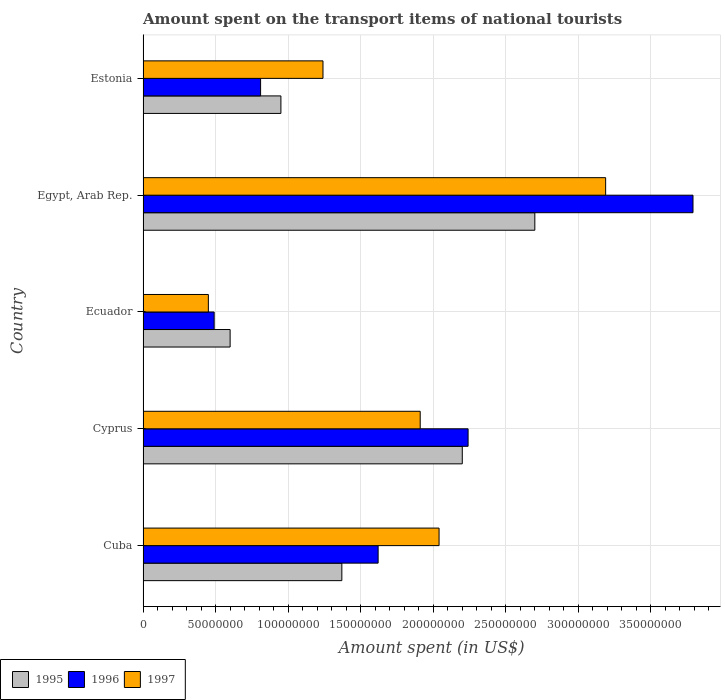How many groups of bars are there?
Your answer should be very brief. 5. Are the number of bars per tick equal to the number of legend labels?
Offer a terse response. Yes. What is the label of the 2nd group of bars from the top?
Your response must be concise. Egypt, Arab Rep. What is the amount spent on the transport items of national tourists in 1996 in Cuba?
Your response must be concise. 1.62e+08. Across all countries, what is the maximum amount spent on the transport items of national tourists in 1997?
Offer a very short reply. 3.19e+08. Across all countries, what is the minimum amount spent on the transport items of national tourists in 1996?
Provide a short and direct response. 4.90e+07. In which country was the amount spent on the transport items of national tourists in 1997 maximum?
Give a very brief answer. Egypt, Arab Rep. In which country was the amount spent on the transport items of national tourists in 1995 minimum?
Ensure brevity in your answer.  Ecuador. What is the total amount spent on the transport items of national tourists in 1995 in the graph?
Give a very brief answer. 7.82e+08. What is the difference between the amount spent on the transport items of national tourists in 1995 in Cuba and that in Estonia?
Make the answer very short. 4.20e+07. What is the difference between the amount spent on the transport items of national tourists in 1997 in Estonia and the amount spent on the transport items of national tourists in 1996 in Cyprus?
Offer a very short reply. -1.00e+08. What is the average amount spent on the transport items of national tourists in 1997 per country?
Give a very brief answer. 1.77e+08. What is the difference between the amount spent on the transport items of national tourists in 1995 and amount spent on the transport items of national tourists in 1997 in Ecuador?
Your answer should be compact. 1.50e+07. What is the ratio of the amount spent on the transport items of national tourists in 1997 in Cuba to that in Egypt, Arab Rep.?
Provide a succinct answer. 0.64. What is the difference between the highest and the second highest amount spent on the transport items of national tourists in 1997?
Make the answer very short. 1.15e+08. What is the difference between the highest and the lowest amount spent on the transport items of national tourists in 1997?
Make the answer very short. 2.74e+08. In how many countries, is the amount spent on the transport items of national tourists in 1996 greater than the average amount spent on the transport items of national tourists in 1996 taken over all countries?
Keep it short and to the point. 2. Is the sum of the amount spent on the transport items of national tourists in 1995 in Cuba and Egypt, Arab Rep. greater than the maximum amount spent on the transport items of national tourists in 1997 across all countries?
Offer a very short reply. Yes. What does the 1st bar from the top in Estonia represents?
Your answer should be very brief. 1997. What does the 2nd bar from the bottom in Egypt, Arab Rep. represents?
Provide a succinct answer. 1996. Is it the case that in every country, the sum of the amount spent on the transport items of national tourists in 1997 and amount spent on the transport items of national tourists in 1996 is greater than the amount spent on the transport items of national tourists in 1995?
Your response must be concise. Yes. How many countries are there in the graph?
Your answer should be very brief. 5. Does the graph contain any zero values?
Give a very brief answer. No. Does the graph contain grids?
Your response must be concise. Yes. How many legend labels are there?
Make the answer very short. 3. How are the legend labels stacked?
Your response must be concise. Horizontal. What is the title of the graph?
Keep it short and to the point. Amount spent on the transport items of national tourists. What is the label or title of the X-axis?
Offer a terse response. Amount spent (in US$). What is the label or title of the Y-axis?
Keep it short and to the point. Country. What is the Amount spent (in US$) in 1995 in Cuba?
Your answer should be compact. 1.37e+08. What is the Amount spent (in US$) of 1996 in Cuba?
Keep it short and to the point. 1.62e+08. What is the Amount spent (in US$) of 1997 in Cuba?
Your response must be concise. 2.04e+08. What is the Amount spent (in US$) of 1995 in Cyprus?
Keep it short and to the point. 2.20e+08. What is the Amount spent (in US$) in 1996 in Cyprus?
Give a very brief answer. 2.24e+08. What is the Amount spent (in US$) of 1997 in Cyprus?
Provide a succinct answer. 1.91e+08. What is the Amount spent (in US$) of 1995 in Ecuador?
Offer a very short reply. 6.00e+07. What is the Amount spent (in US$) in 1996 in Ecuador?
Offer a terse response. 4.90e+07. What is the Amount spent (in US$) in 1997 in Ecuador?
Ensure brevity in your answer.  4.50e+07. What is the Amount spent (in US$) of 1995 in Egypt, Arab Rep.?
Offer a terse response. 2.70e+08. What is the Amount spent (in US$) in 1996 in Egypt, Arab Rep.?
Offer a terse response. 3.79e+08. What is the Amount spent (in US$) of 1997 in Egypt, Arab Rep.?
Ensure brevity in your answer.  3.19e+08. What is the Amount spent (in US$) of 1995 in Estonia?
Ensure brevity in your answer.  9.50e+07. What is the Amount spent (in US$) of 1996 in Estonia?
Keep it short and to the point. 8.10e+07. What is the Amount spent (in US$) in 1997 in Estonia?
Your response must be concise. 1.24e+08. Across all countries, what is the maximum Amount spent (in US$) of 1995?
Give a very brief answer. 2.70e+08. Across all countries, what is the maximum Amount spent (in US$) of 1996?
Offer a very short reply. 3.79e+08. Across all countries, what is the maximum Amount spent (in US$) of 1997?
Provide a succinct answer. 3.19e+08. Across all countries, what is the minimum Amount spent (in US$) in 1995?
Offer a terse response. 6.00e+07. Across all countries, what is the minimum Amount spent (in US$) of 1996?
Your response must be concise. 4.90e+07. Across all countries, what is the minimum Amount spent (in US$) in 1997?
Give a very brief answer. 4.50e+07. What is the total Amount spent (in US$) of 1995 in the graph?
Provide a succinct answer. 7.82e+08. What is the total Amount spent (in US$) of 1996 in the graph?
Your answer should be compact. 8.95e+08. What is the total Amount spent (in US$) in 1997 in the graph?
Ensure brevity in your answer.  8.83e+08. What is the difference between the Amount spent (in US$) of 1995 in Cuba and that in Cyprus?
Your answer should be very brief. -8.30e+07. What is the difference between the Amount spent (in US$) in 1996 in Cuba and that in Cyprus?
Make the answer very short. -6.20e+07. What is the difference between the Amount spent (in US$) of 1997 in Cuba and that in Cyprus?
Provide a short and direct response. 1.30e+07. What is the difference between the Amount spent (in US$) in 1995 in Cuba and that in Ecuador?
Keep it short and to the point. 7.70e+07. What is the difference between the Amount spent (in US$) in 1996 in Cuba and that in Ecuador?
Ensure brevity in your answer.  1.13e+08. What is the difference between the Amount spent (in US$) in 1997 in Cuba and that in Ecuador?
Your answer should be very brief. 1.59e+08. What is the difference between the Amount spent (in US$) of 1995 in Cuba and that in Egypt, Arab Rep.?
Provide a short and direct response. -1.33e+08. What is the difference between the Amount spent (in US$) of 1996 in Cuba and that in Egypt, Arab Rep.?
Make the answer very short. -2.17e+08. What is the difference between the Amount spent (in US$) in 1997 in Cuba and that in Egypt, Arab Rep.?
Your response must be concise. -1.15e+08. What is the difference between the Amount spent (in US$) of 1995 in Cuba and that in Estonia?
Your response must be concise. 4.20e+07. What is the difference between the Amount spent (in US$) of 1996 in Cuba and that in Estonia?
Offer a terse response. 8.10e+07. What is the difference between the Amount spent (in US$) of 1997 in Cuba and that in Estonia?
Give a very brief answer. 8.00e+07. What is the difference between the Amount spent (in US$) of 1995 in Cyprus and that in Ecuador?
Provide a succinct answer. 1.60e+08. What is the difference between the Amount spent (in US$) of 1996 in Cyprus and that in Ecuador?
Provide a succinct answer. 1.75e+08. What is the difference between the Amount spent (in US$) of 1997 in Cyprus and that in Ecuador?
Your answer should be compact. 1.46e+08. What is the difference between the Amount spent (in US$) of 1995 in Cyprus and that in Egypt, Arab Rep.?
Offer a very short reply. -5.00e+07. What is the difference between the Amount spent (in US$) in 1996 in Cyprus and that in Egypt, Arab Rep.?
Offer a terse response. -1.55e+08. What is the difference between the Amount spent (in US$) of 1997 in Cyprus and that in Egypt, Arab Rep.?
Ensure brevity in your answer.  -1.28e+08. What is the difference between the Amount spent (in US$) of 1995 in Cyprus and that in Estonia?
Offer a terse response. 1.25e+08. What is the difference between the Amount spent (in US$) in 1996 in Cyprus and that in Estonia?
Offer a terse response. 1.43e+08. What is the difference between the Amount spent (in US$) of 1997 in Cyprus and that in Estonia?
Provide a succinct answer. 6.70e+07. What is the difference between the Amount spent (in US$) of 1995 in Ecuador and that in Egypt, Arab Rep.?
Provide a succinct answer. -2.10e+08. What is the difference between the Amount spent (in US$) of 1996 in Ecuador and that in Egypt, Arab Rep.?
Your answer should be compact. -3.30e+08. What is the difference between the Amount spent (in US$) in 1997 in Ecuador and that in Egypt, Arab Rep.?
Provide a short and direct response. -2.74e+08. What is the difference between the Amount spent (in US$) in 1995 in Ecuador and that in Estonia?
Your answer should be compact. -3.50e+07. What is the difference between the Amount spent (in US$) of 1996 in Ecuador and that in Estonia?
Your response must be concise. -3.20e+07. What is the difference between the Amount spent (in US$) in 1997 in Ecuador and that in Estonia?
Offer a very short reply. -7.90e+07. What is the difference between the Amount spent (in US$) of 1995 in Egypt, Arab Rep. and that in Estonia?
Provide a succinct answer. 1.75e+08. What is the difference between the Amount spent (in US$) of 1996 in Egypt, Arab Rep. and that in Estonia?
Give a very brief answer. 2.98e+08. What is the difference between the Amount spent (in US$) of 1997 in Egypt, Arab Rep. and that in Estonia?
Make the answer very short. 1.95e+08. What is the difference between the Amount spent (in US$) of 1995 in Cuba and the Amount spent (in US$) of 1996 in Cyprus?
Provide a succinct answer. -8.70e+07. What is the difference between the Amount spent (in US$) in 1995 in Cuba and the Amount spent (in US$) in 1997 in Cyprus?
Your answer should be compact. -5.40e+07. What is the difference between the Amount spent (in US$) of 1996 in Cuba and the Amount spent (in US$) of 1997 in Cyprus?
Offer a terse response. -2.90e+07. What is the difference between the Amount spent (in US$) in 1995 in Cuba and the Amount spent (in US$) in 1996 in Ecuador?
Your response must be concise. 8.80e+07. What is the difference between the Amount spent (in US$) in 1995 in Cuba and the Amount spent (in US$) in 1997 in Ecuador?
Your answer should be very brief. 9.20e+07. What is the difference between the Amount spent (in US$) of 1996 in Cuba and the Amount spent (in US$) of 1997 in Ecuador?
Your answer should be compact. 1.17e+08. What is the difference between the Amount spent (in US$) of 1995 in Cuba and the Amount spent (in US$) of 1996 in Egypt, Arab Rep.?
Give a very brief answer. -2.42e+08. What is the difference between the Amount spent (in US$) in 1995 in Cuba and the Amount spent (in US$) in 1997 in Egypt, Arab Rep.?
Ensure brevity in your answer.  -1.82e+08. What is the difference between the Amount spent (in US$) in 1996 in Cuba and the Amount spent (in US$) in 1997 in Egypt, Arab Rep.?
Make the answer very short. -1.57e+08. What is the difference between the Amount spent (in US$) in 1995 in Cuba and the Amount spent (in US$) in 1996 in Estonia?
Your answer should be compact. 5.60e+07. What is the difference between the Amount spent (in US$) of 1995 in Cuba and the Amount spent (in US$) of 1997 in Estonia?
Your answer should be compact. 1.30e+07. What is the difference between the Amount spent (in US$) of 1996 in Cuba and the Amount spent (in US$) of 1997 in Estonia?
Give a very brief answer. 3.80e+07. What is the difference between the Amount spent (in US$) of 1995 in Cyprus and the Amount spent (in US$) of 1996 in Ecuador?
Provide a short and direct response. 1.71e+08. What is the difference between the Amount spent (in US$) of 1995 in Cyprus and the Amount spent (in US$) of 1997 in Ecuador?
Keep it short and to the point. 1.75e+08. What is the difference between the Amount spent (in US$) of 1996 in Cyprus and the Amount spent (in US$) of 1997 in Ecuador?
Keep it short and to the point. 1.79e+08. What is the difference between the Amount spent (in US$) of 1995 in Cyprus and the Amount spent (in US$) of 1996 in Egypt, Arab Rep.?
Offer a very short reply. -1.59e+08. What is the difference between the Amount spent (in US$) in 1995 in Cyprus and the Amount spent (in US$) in 1997 in Egypt, Arab Rep.?
Your answer should be very brief. -9.88e+07. What is the difference between the Amount spent (in US$) in 1996 in Cyprus and the Amount spent (in US$) in 1997 in Egypt, Arab Rep.?
Your response must be concise. -9.48e+07. What is the difference between the Amount spent (in US$) in 1995 in Cyprus and the Amount spent (in US$) in 1996 in Estonia?
Your response must be concise. 1.39e+08. What is the difference between the Amount spent (in US$) of 1995 in Cyprus and the Amount spent (in US$) of 1997 in Estonia?
Your answer should be compact. 9.60e+07. What is the difference between the Amount spent (in US$) of 1996 in Cyprus and the Amount spent (in US$) of 1997 in Estonia?
Provide a short and direct response. 1.00e+08. What is the difference between the Amount spent (in US$) of 1995 in Ecuador and the Amount spent (in US$) of 1996 in Egypt, Arab Rep.?
Your answer should be very brief. -3.19e+08. What is the difference between the Amount spent (in US$) of 1995 in Ecuador and the Amount spent (in US$) of 1997 in Egypt, Arab Rep.?
Keep it short and to the point. -2.59e+08. What is the difference between the Amount spent (in US$) in 1996 in Ecuador and the Amount spent (in US$) in 1997 in Egypt, Arab Rep.?
Make the answer very short. -2.70e+08. What is the difference between the Amount spent (in US$) in 1995 in Ecuador and the Amount spent (in US$) in 1996 in Estonia?
Your answer should be compact. -2.10e+07. What is the difference between the Amount spent (in US$) of 1995 in Ecuador and the Amount spent (in US$) of 1997 in Estonia?
Offer a very short reply. -6.40e+07. What is the difference between the Amount spent (in US$) in 1996 in Ecuador and the Amount spent (in US$) in 1997 in Estonia?
Your answer should be very brief. -7.50e+07. What is the difference between the Amount spent (in US$) of 1995 in Egypt, Arab Rep. and the Amount spent (in US$) of 1996 in Estonia?
Your response must be concise. 1.89e+08. What is the difference between the Amount spent (in US$) of 1995 in Egypt, Arab Rep. and the Amount spent (in US$) of 1997 in Estonia?
Ensure brevity in your answer.  1.46e+08. What is the difference between the Amount spent (in US$) of 1996 in Egypt, Arab Rep. and the Amount spent (in US$) of 1997 in Estonia?
Offer a terse response. 2.55e+08. What is the average Amount spent (in US$) in 1995 per country?
Provide a succinct answer. 1.56e+08. What is the average Amount spent (in US$) of 1996 per country?
Offer a terse response. 1.79e+08. What is the average Amount spent (in US$) in 1997 per country?
Your answer should be very brief. 1.77e+08. What is the difference between the Amount spent (in US$) of 1995 and Amount spent (in US$) of 1996 in Cuba?
Provide a short and direct response. -2.50e+07. What is the difference between the Amount spent (in US$) of 1995 and Amount spent (in US$) of 1997 in Cuba?
Your answer should be compact. -6.70e+07. What is the difference between the Amount spent (in US$) of 1996 and Amount spent (in US$) of 1997 in Cuba?
Offer a very short reply. -4.20e+07. What is the difference between the Amount spent (in US$) in 1995 and Amount spent (in US$) in 1996 in Cyprus?
Your answer should be very brief. -4.00e+06. What is the difference between the Amount spent (in US$) of 1995 and Amount spent (in US$) of 1997 in Cyprus?
Your answer should be compact. 2.90e+07. What is the difference between the Amount spent (in US$) of 1996 and Amount spent (in US$) of 1997 in Cyprus?
Make the answer very short. 3.30e+07. What is the difference between the Amount spent (in US$) of 1995 and Amount spent (in US$) of 1996 in Ecuador?
Offer a very short reply. 1.10e+07. What is the difference between the Amount spent (in US$) of 1995 and Amount spent (in US$) of 1997 in Ecuador?
Offer a terse response. 1.50e+07. What is the difference between the Amount spent (in US$) of 1995 and Amount spent (in US$) of 1996 in Egypt, Arab Rep.?
Keep it short and to the point. -1.09e+08. What is the difference between the Amount spent (in US$) of 1995 and Amount spent (in US$) of 1997 in Egypt, Arab Rep.?
Your response must be concise. -4.88e+07. What is the difference between the Amount spent (in US$) in 1996 and Amount spent (in US$) in 1997 in Egypt, Arab Rep.?
Give a very brief answer. 6.02e+07. What is the difference between the Amount spent (in US$) in 1995 and Amount spent (in US$) in 1996 in Estonia?
Provide a short and direct response. 1.40e+07. What is the difference between the Amount spent (in US$) of 1995 and Amount spent (in US$) of 1997 in Estonia?
Provide a short and direct response. -2.90e+07. What is the difference between the Amount spent (in US$) of 1996 and Amount spent (in US$) of 1997 in Estonia?
Give a very brief answer. -4.30e+07. What is the ratio of the Amount spent (in US$) of 1995 in Cuba to that in Cyprus?
Offer a terse response. 0.62. What is the ratio of the Amount spent (in US$) in 1996 in Cuba to that in Cyprus?
Make the answer very short. 0.72. What is the ratio of the Amount spent (in US$) of 1997 in Cuba to that in Cyprus?
Your answer should be very brief. 1.07. What is the ratio of the Amount spent (in US$) of 1995 in Cuba to that in Ecuador?
Offer a very short reply. 2.28. What is the ratio of the Amount spent (in US$) in 1996 in Cuba to that in Ecuador?
Give a very brief answer. 3.31. What is the ratio of the Amount spent (in US$) in 1997 in Cuba to that in Ecuador?
Your response must be concise. 4.53. What is the ratio of the Amount spent (in US$) of 1995 in Cuba to that in Egypt, Arab Rep.?
Ensure brevity in your answer.  0.51. What is the ratio of the Amount spent (in US$) of 1996 in Cuba to that in Egypt, Arab Rep.?
Offer a terse response. 0.43. What is the ratio of the Amount spent (in US$) in 1997 in Cuba to that in Egypt, Arab Rep.?
Provide a short and direct response. 0.64. What is the ratio of the Amount spent (in US$) in 1995 in Cuba to that in Estonia?
Your answer should be compact. 1.44. What is the ratio of the Amount spent (in US$) of 1996 in Cuba to that in Estonia?
Your answer should be very brief. 2. What is the ratio of the Amount spent (in US$) of 1997 in Cuba to that in Estonia?
Keep it short and to the point. 1.65. What is the ratio of the Amount spent (in US$) in 1995 in Cyprus to that in Ecuador?
Provide a succinct answer. 3.67. What is the ratio of the Amount spent (in US$) of 1996 in Cyprus to that in Ecuador?
Your answer should be very brief. 4.57. What is the ratio of the Amount spent (in US$) of 1997 in Cyprus to that in Ecuador?
Offer a very short reply. 4.24. What is the ratio of the Amount spent (in US$) of 1995 in Cyprus to that in Egypt, Arab Rep.?
Your answer should be compact. 0.81. What is the ratio of the Amount spent (in US$) of 1996 in Cyprus to that in Egypt, Arab Rep.?
Offer a terse response. 0.59. What is the ratio of the Amount spent (in US$) in 1997 in Cyprus to that in Egypt, Arab Rep.?
Provide a succinct answer. 0.6. What is the ratio of the Amount spent (in US$) of 1995 in Cyprus to that in Estonia?
Keep it short and to the point. 2.32. What is the ratio of the Amount spent (in US$) of 1996 in Cyprus to that in Estonia?
Make the answer very short. 2.77. What is the ratio of the Amount spent (in US$) of 1997 in Cyprus to that in Estonia?
Ensure brevity in your answer.  1.54. What is the ratio of the Amount spent (in US$) in 1995 in Ecuador to that in Egypt, Arab Rep.?
Keep it short and to the point. 0.22. What is the ratio of the Amount spent (in US$) in 1996 in Ecuador to that in Egypt, Arab Rep.?
Offer a terse response. 0.13. What is the ratio of the Amount spent (in US$) of 1997 in Ecuador to that in Egypt, Arab Rep.?
Ensure brevity in your answer.  0.14. What is the ratio of the Amount spent (in US$) in 1995 in Ecuador to that in Estonia?
Ensure brevity in your answer.  0.63. What is the ratio of the Amount spent (in US$) in 1996 in Ecuador to that in Estonia?
Keep it short and to the point. 0.6. What is the ratio of the Amount spent (in US$) of 1997 in Ecuador to that in Estonia?
Keep it short and to the point. 0.36. What is the ratio of the Amount spent (in US$) in 1995 in Egypt, Arab Rep. to that in Estonia?
Ensure brevity in your answer.  2.84. What is the ratio of the Amount spent (in US$) of 1996 in Egypt, Arab Rep. to that in Estonia?
Provide a short and direct response. 4.68. What is the ratio of the Amount spent (in US$) of 1997 in Egypt, Arab Rep. to that in Estonia?
Provide a short and direct response. 2.57. What is the difference between the highest and the second highest Amount spent (in US$) of 1995?
Ensure brevity in your answer.  5.00e+07. What is the difference between the highest and the second highest Amount spent (in US$) of 1996?
Offer a terse response. 1.55e+08. What is the difference between the highest and the second highest Amount spent (in US$) of 1997?
Your answer should be compact. 1.15e+08. What is the difference between the highest and the lowest Amount spent (in US$) in 1995?
Ensure brevity in your answer.  2.10e+08. What is the difference between the highest and the lowest Amount spent (in US$) in 1996?
Make the answer very short. 3.30e+08. What is the difference between the highest and the lowest Amount spent (in US$) of 1997?
Your response must be concise. 2.74e+08. 